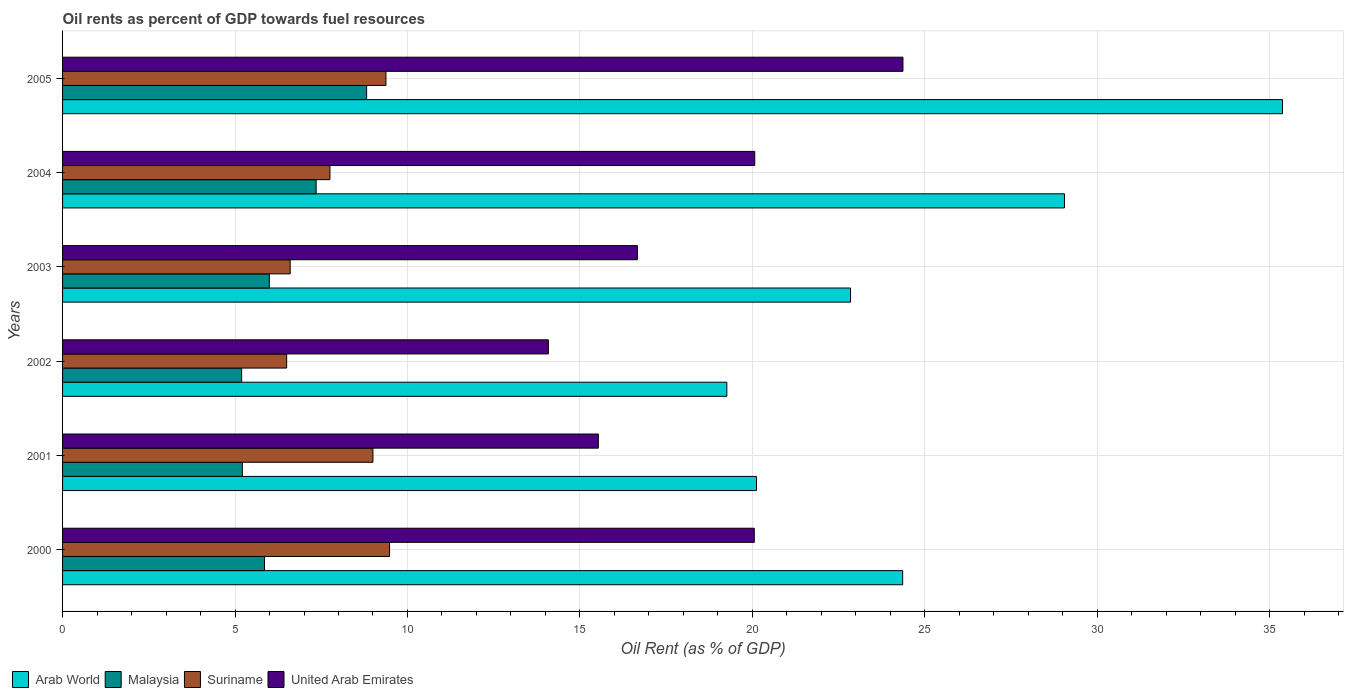How many different coloured bars are there?
Keep it short and to the point. 4. What is the oil rent in Arab World in 2001?
Your response must be concise. 20.12. Across all years, what is the maximum oil rent in Arab World?
Provide a short and direct response. 35.37. Across all years, what is the minimum oil rent in Suriname?
Offer a very short reply. 6.5. In which year was the oil rent in Arab World minimum?
Give a very brief answer. 2002. What is the total oil rent in Malaysia in the graph?
Make the answer very short. 38.42. What is the difference between the oil rent in Arab World in 2000 and that in 2003?
Keep it short and to the point. 1.51. What is the difference between the oil rent in United Arab Emirates in 2004 and the oil rent in Malaysia in 2002?
Keep it short and to the point. 14.88. What is the average oil rent in Arab World per year?
Your response must be concise. 25.17. In the year 2005, what is the difference between the oil rent in United Arab Emirates and oil rent in Malaysia?
Your response must be concise. 15.55. What is the ratio of the oil rent in Suriname in 2000 to that in 2001?
Keep it short and to the point. 1.05. Is the oil rent in Arab World in 2002 less than that in 2004?
Keep it short and to the point. Yes. What is the difference between the highest and the second highest oil rent in Suriname?
Your answer should be compact. 0.11. What is the difference between the highest and the lowest oil rent in Arab World?
Provide a short and direct response. 16.11. In how many years, is the oil rent in Arab World greater than the average oil rent in Arab World taken over all years?
Provide a succinct answer. 2. Is the sum of the oil rent in Malaysia in 2001 and 2005 greater than the maximum oil rent in Arab World across all years?
Keep it short and to the point. No. What does the 1st bar from the top in 2003 represents?
Your answer should be very brief. United Arab Emirates. What does the 4th bar from the bottom in 2004 represents?
Your answer should be compact. United Arab Emirates. How many bars are there?
Your answer should be very brief. 24. Are all the bars in the graph horizontal?
Make the answer very short. Yes. What is the difference between two consecutive major ticks on the X-axis?
Ensure brevity in your answer.  5. Are the values on the major ticks of X-axis written in scientific E-notation?
Your answer should be very brief. No. Does the graph contain any zero values?
Your response must be concise. No. Does the graph contain grids?
Your answer should be very brief. Yes. How many legend labels are there?
Your answer should be compact. 4. What is the title of the graph?
Offer a terse response. Oil rents as percent of GDP towards fuel resources. Does "French Polynesia" appear as one of the legend labels in the graph?
Offer a very short reply. No. What is the label or title of the X-axis?
Ensure brevity in your answer.  Oil Rent (as % of GDP). What is the label or title of the Y-axis?
Provide a succinct answer. Years. What is the Oil Rent (as % of GDP) in Arab World in 2000?
Ensure brevity in your answer.  24.36. What is the Oil Rent (as % of GDP) of Malaysia in 2000?
Ensure brevity in your answer.  5.85. What is the Oil Rent (as % of GDP) in Suriname in 2000?
Your answer should be compact. 9.48. What is the Oil Rent (as % of GDP) in United Arab Emirates in 2000?
Offer a terse response. 20.06. What is the Oil Rent (as % of GDP) in Arab World in 2001?
Give a very brief answer. 20.12. What is the Oil Rent (as % of GDP) in Malaysia in 2001?
Your answer should be very brief. 5.21. What is the Oil Rent (as % of GDP) of Suriname in 2001?
Keep it short and to the point. 9. What is the Oil Rent (as % of GDP) of United Arab Emirates in 2001?
Your answer should be compact. 15.53. What is the Oil Rent (as % of GDP) of Arab World in 2002?
Ensure brevity in your answer.  19.26. What is the Oil Rent (as % of GDP) of Malaysia in 2002?
Make the answer very short. 5.19. What is the Oil Rent (as % of GDP) in Suriname in 2002?
Provide a short and direct response. 6.5. What is the Oil Rent (as % of GDP) in United Arab Emirates in 2002?
Make the answer very short. 14.09. What is the Oil Rent (as % of GDP) of Arab World in 2003?
Your answer should be compact. 22.85. What is the Oil Rent (as % of GDP) of Malaysia in 2003?
Ensure brevity in your answer.  5.99. What is the Oil Rent (as % of GDP) in Suriname in 2003?
Provide a short and direct response. 6.6. What is the Oil Rent (as % of GDP) in United Arab Emirates in 2003?
Make the answer very short. 16.67. What is the Oil Rent (as % of GDP) in Arab World in 2004?
Your answer should be very brief. 29.05. What is the Oil Rent (as % of GDP) in Malaysia in 2004?
Your response must be concise. 7.35. What is the Oil Rent (as % of GDP) in Suriname in 2004?
Offer a terse response. 7.75. What is the Oil Rent (as % of GDP) of United Arab Emirates in 2004?
Make the answer very short. 20.07. What is the Oil Rent (as % of GDP) in Arab World in 2005?
Provide a short and direct response. 35.37. What is the Oil Rent (as % of GDP) of Malaysia in 2005?
Your answer should be very brief. 8.82. What is the Oil Rent (as % of GDP) of Suriname in 2005?
Offer a terse response. 9.38. What is the Oil Rent (as % of GDP) of United Arab Emirates in 2005?
Provide a succinct answer. 24.37. Across all years, what is the maximum Oil Rent (as % of GDP) in Arab World?
Offer a terse response. 35.37. Across all years, what is the maximum Oil Rent (as % of GDP) of Malaysia?
Your response must be concise. 8.82. Across all years, what is the maximum Oil Rent (as % of GDP) of Suriname?
Ensure brevity in your answer.  9.48. Across all years, what is the maximum Oil Rent (as % of GDP) in United Arab Emirates?
Make the answer very short. 24.37. Across all years, what is the minimum Oil Rent (as % of GDP) in Arab World?
Give a very brief answer. 19.26. Across all years, what is the minimum Oil Rent (as % of GDP) in Malaysia?
Offer a very short reply. 5.19. Across all years, what is the minimum Oil Rent (as % of GDP) of Suriname?
Your response must be concise. 6.5. Across all years, what is the minimum Oil Rent (as % of GDP) of United Arab Emirates?
Provide a succinct answer. 14.09. What is the total Oil Rent (as % of GDP) of Arab World in the graph?
Ensure brevity in your answer.  151. What is the total Oil Rent (as % of GDP) in Malaysia in the graph?
Your response must be concise. 38.42. What is the total Oil Rent (as % of GDP) in Suriname in the graph?
Offer a terse response. 48.7. What is the total Oil Rent (as % of GDP) of United Arab Emirates in the graph?
Give a very brief answer. 110.78. What is the difference between the Oil Rent (as % of GDP) in Arab World in 2000 and that in 2001?
Your answer should be compact. 4.24. What is the difference between the Oil Rent (as % of GDP) of Malaysia in 2000 and that in 2001?
Offer a very short reply. 0.64. What is the difference between the Oil Rent (as % of GDP) in Suriname in 2000 and that in 2001?
Your answer should be compact. 0.48. What is the difference between the Oil Rent (as % of GDP) in United Arab Emirates in 2000 and that in 2001?
Offer a terse response. 4.52. What is the difference between the Oil Rent (as % of GDP) of Arab World in 2000 and that in 2002?
Your response must be concise. 5.1. What is the difference between the Oil Rent (as % of GDP) in Malaysia in 2000 and that in 2002?
Your answer should be compact. 0.66. What is the difference between the Oil Rent (as % of GDP) in Suriname in 2000 and that in 2002?
Offer a terse response. 2.98. What is the difference between the Oil Rent (as % of GDP) of United Arab Emirates in 2000 and that in 2002?
Offer a terse response. 5.97. What is the difference between the Oil Rent (as % of GDP) in Arab World in 2000 and that in 2003?
Offer a very short reply. 1.51. What is the difference between the Oil Rent (as % of GDP) of Malaysia in 2000 and that in 2003?
Provide a succinct answer. -0.14. What is the difference between the Oil Rent (as % of GDP) in Suriname in 2000 and that in 2003?
Give a very brief answer. 2.88. What is the difference between the Oil Rent (as % of GDP) of United Arab Emirates in 2000 and that in 2003?
Make the answer very short. 3.39. What is the difference between the Oil Rent (as % of GDP) in Arab World in 2000 and that in 2004?
Make the answer very short. -4.69. What is the difference between the Oil Rent (as % of GDP) of Malaysia in 2000 and that in 2004?
Offer a terse response. -1.5. What is the difference between the Oil Rent (as % of GDP) of Suriname in 2000 and that in 2004?
Your answer should be compact. 1.73. What is the difference between the Oil Rent (as % of GDP) in United Arab Emirates in 2000 and that in 2004?
Offer a very short reply. -0.01. What is the difference between the Oil Rent (as % of GDP) in Arab World in 2000 and that in 2005?
Provide a short and direct response. -11.01. What is the difference between the Oil Rent (as % of GDP) in Malaysia in 2000 and that in 2005?
Provide a short and direct response. -2.96. What is the difference between the Oil Rent (as % of GDP) in Suriname in 2000 and that in 2005?
Give a very brief answer. 0.11. What is the difference between the Oil Rent (as % of GDP) in United Arab Emirates in 2000 and that in 2005?
Ensure brevity in your answer.  -4.31. What is the difference between the Oil Rent (as % of GDP) in Arab World in 2001 and that in 2002?
Keep it short and to the point. 0.86. What is the difference between the Oil Rent (as % of GDP) of Malaysia in 2001 and that in 2002?
Give a very brief answer. 0.02. What is the difference between the Oil Rent (as % of GDP) in Suriname in 2001 and that in 2002?
Keep it short and to the point. 2.5. What is the difference between the Oil Rent (as % of GDP) of United Arab Emirates in 2001 and that in 2002?
Your answer should be compact. 1.45. What is the difference between the Oil Rent (as % of GDP) of Arab World in 2001 and that in 2003?
Your answer should be compact. -2.73. What is the difference between the Oil Rent (as % of GDP) in Malaysia in 2001 and that in 2003?
Keep it short and to the point. -0.78. What is the difference between the Oil Rent (as % of GDP) of Suriname in 2001 and that in 2003?
Your answer should be compact. 2.4. What is the difference between the Oil Rent (as % of GDP) of United Arab Emirates in 2001 and that in 2003?
Your answer should be very brief. -1.13. What is the difference between the Oil Rent (as % of GDP) in Arab World in 2001 and that in 2004?
Keep it short and to the point. -8.93. What is the difference between the Oil Rent (as % of GDP) of Malaysia in 2001 and that in 2004?
Provide a succinct answer. -2.14. What is the difference between the Oil Rent (as % of GDP) in Suriname in 2001 and that in 2004?
Your answer should be very brief. 1.25. What is the difference between the Oil Rent (as % of GDP) in United Arab Emirates in 2001 and that in 2004?
Your answer should be compact. -4.53. What is the difference between the Oil Rent (as % of GDP) of Arab World in 2001 and that in 2005?
Your response must be concise. -15.25. What is the difference between the Oil Rent (as % of GDP) in Malaysia in 2001 and that in 2005?
Provide a short and direct response. -3.6. What is the difference between the Oil Rent (as % of GDP) in Suriname in 2001 and that in 2005?
Offer a very short reply. -0.38. What is the difference between the Oil Rent (as % of GDP) in United Arab Emirates in 2001 and that in 2005?
Provide a succinct answer. -8.83. What is the difference between the Oil Rent (as % of GDP) in Arab World in 2002 and that in 2003?
Provide a short and direct response. -3.59. What is the difference between the Oil Rent (as % of GDP) in Malaysia in 2002 and that in 2003?
Give a very brief answer. -0.8. What is the difference between the Oil Rent (as % of GDP) in Suriname in 2002 and that in 2003?
Offer a terse response. -0.1. What is the difference between the Oil Rent (as % of GDP) in United Arab Emirates in 2002 and that in 2003?
Make the answer very short. -2.58. What is the difference between the Oil Rent (as % of GDP) in Arab World in 2002 and that in 2004?
Keep it short and to the point. -9.79. What is the difference between the Oil Rent (as % of GDP) of Malaysia in 2002 and that in 2004?
Provide a succinct answer. -2.16. What is the difference between the Oil Rent (as % of GDP) in Suriname in 2002 and that in 2004?
Offer a terse response. -1.25. What is the difference between the Oil Rent (as % of GDP) in United Arab Emirates in 2002 and that in 2004?
Your answer should be very brief. -5.98. What is the difference between the Oil Rent (as % of GDP) of Arab World in 2002 and that in 2005?
Your answer should be very brief. -16.11. What is the difference between the Oil Rent (as % of GDP) in Malaysia in 2002 and that in 2005?
Ensure brevity in your answer.  -3.62. What is the difference between the Oil Rent (as % of GDP) of Suriname in 2002 and that in 2005?
Make the answer very short. -2.88. What is the difference between the Oil Rent (as % of GDP) in United Arab Emirates in 2002 and that in 2005?
Give a very brief answer. -10.28. What is the difference between the Oil Rent (as % of GDP) in Arab World in 2003 and that in 2004?
Your answer should be compact. -6.2. What is the difference between the Oil Rent (as % of GDP) in Malaysia in 2003 and that in 2004?
Offer a terse response. -1.36. What is the difference between the Oil Rent (as % of GDP) of Suriname in 2003 and that in 2004?
Provide a short and direct response. -1.15. What is the difference between the Oil Rent (as % of GDP) in United Arab Emirates in 2003 and that in 2004?
Offer a very short reply. -3.4. What is the difference between the Oil Rent (as % of GDP) of Arab World in 2003 and that in 2005?
Provide a short and direct response. -12.52. What is the difference between the Oil Rent (as % of GDP) of Malaysia in 2003 and that in 2005?
Your answer should be compact. -2.82. What is the difference between the Oil Rent (as % of GDP) of Suriname in 2003 and that in 2005?
Your answer should be very brief. -2.78. What is the difference between the Oil Rent (as % of GDP) in United Arab Emirates in 2003 and that in 2005?
Your answer should be compact. -7.7. What is the difference between the Oil Rent (as % of GDP) of Arab World in 2004 and that in 2005?
Your answer should be very brief. -6.32. What is the difference between the Oil Rent (as % of GDP) in Malaysia in 2004 and that in 2005?
Give a very brief answer. -1.46. What is the difference between the Oil Rent (as % of GDP) in Suriname in 2004 and that in 2005?
Ensure brevity in your answer.  -1.62. What is the difference between the Oil Rent (as % of GDP) of United Arab Emirates in 2004 and that in 2005?
Provide a succinct answer. -4.3. What is the difference between the Oil Rent (as % of GDP) in Arab World in 2000 and the Oil Rent (as % of GDP) in Malaysia in 2001?
Your answer should be compact. 19.14. What is the difference between the Oil Rent (as % of GDP) of Arab World in 2000 and the Oil Rent (as % of GDP) of Suriname in 2001?
Provide a succinct answer. 15.36. What is the difference between the Oil Rent (as % of GDP) of Arab World in 2000 and the Oil Rent (as % of GDP) of United Arab Emirates in 2001?
Offer a terse response. 8.82. What is the difference between the Oil Rent (as % of GDP) of Malaysia in 2000 and the Oil Rent (as % of GDP) of Suriname in 2001?
Offer a terse response. -3.14. What is the difference between the Oil Rent (as % of GDP) of Malaysia in 2000 and the Oil Rent (as % of GDP) of United Arab Emirates in 2001?
Keep it short and to the point. -9.68. What is the difference between the Oil Rent (as % of GDP) in Suriname in 2000 and the Oil Rent (as % of GDP) in United Arab Emirates in 2001?
Offer a terse response. -6.05. What is the difference between the Oil Rent (as % of GDP) in Arab World in 2000 and the Oil Rent (as % of GDP) in Malaysia in 2002?
Ensure brevity in your answer.  19.16. What is the difference between the Oil Rent (as % of GDP) in Arab World in 2000 and the Oil Rent (as % of GDP) in Suriname in 2002?
Your answer should be compact. 17.86. What is the difference between the Oil Rent (as % of GDP) in Arab World in 2000 and the Oil Rent (as % of GDP) in United Arab Emirates in 2002?
Give a very brief answer. 10.27. What is the difference between the Oil Rent (as % of GDP) of Malaysia in 2000 and the Oil Rent (as % of GDP) of Suriname in 2002?
Offer a terse response. -0.64. What is the difference between the Oil Rent (as % of GDP) of Malaysia in 2000 and the Oil Rent (as % of GDP) of United Arab Emirates in 2002?
Your answer should be compact. -8.23. What is the difference between the Oil Rent (as % of GDP) in Suriname in 2000 and the Oil Rent (as % of GDP) in United Arab Emirates in 2002?
Your answer should be very brief. -4.6. What is the difference between the Oil Rent (as % of GDP) in Arab World in 2000 and the Oil Rent (as % of GDP) in Malaysia in 2003?
Provide a short and direct response. 18.36. What is the difference between the Oil Rent (as % of GDP) in Arab World in 2000 and the Oil Rent (as % of GDP) in Suriname in 2003?
Keep it short and to the point. 17.76. What is the difference between the Oil Rent (as % of GDP) in Arab World in 2000 and the Oil Rent (as % of GDP) in United Arab Emirates in 2003?
Provide a short and direct response. 7.69. What is the difference between the Oil Rent (as % of GDP) of Malaysia in 2000 and the Oil Rent (as % of GDP) of Suriname in 2003?
Make the answer very short. -0.74. What is the difference between the Oil Rent (as % of GDP) of Malaysia in 2000 and the Oil Rent (as % of GDP) of United Arab Emirates in 2003?
Ensure brevity in your answer.  -10.81. What is the difference between the Oil Rent (as % of GDP) of Suriname in 2000 and the Oil Rent (as % of GDP) of United Arab Emirates in 2003?
Ensure brevity in your answer.  -7.19. What is the difference between the Oil Rent (as % of GDP) of Arab World in 2000 and the Oil Rent (as % of GDP) of Malaysia in 2004?
Your response must be concise. 17.01. What is the difference between the Oil Rent (as % of GDP) in Arab World in 2000 and the Oil Rent (as % of GDP) in Suriname in 2004?
Keep it short and to the point. 16.61. What is the difference between the Oil Rent (as % of GDP) in Arab World in 2000 and the Oil Rent (as % of GDP) in United Arab Emirates in 2004?
Make the answer very short. 4.29. What is the difference between the Oil Rent (as % of GDP) of Malaysia in 2000 and the Oil Rent (as % of GDP) of Suriname in 2004?
Offer a terse response. -1.9. What is the difference between the Oil Rent (as % of GDP) in Malaysia in 2000 and the Oil Rent (as % of GDP) in United Arab Emirates in 2004?
Your answer should be very brief. -14.21. What is the difference between the Oil Rent (as % of GDP) of Suriname in 2000 and the Oil Rent (as % of GDP) of United Arab Emirates in 2004?
Provide a succinct answer. -10.59. What is the difference between the Oil Rent (as % of GDP) of Arab World in 2000 and the Oil Rent (as % of GDP) of Malaysia in 2005?
Your answer should be very brief. 15.54. What is the difference between the Oil Rent (as % of GDP) of Arab World in 2000 and the Oil Rent (as % of GDP) of Suriname in 2005?
Offer a terse response. 14.98. What is the difference between the Oil Rent (as % of GDP) of Arab World in 2000 and the Oil Rent (as % of GDP) of United Arab Emirates in 2005?
Your response must be concise. -0.01. What is the difference between the Oil Rent (as % of GDP) of Malaysia in 2000 and the Oil Rent (as % of GDP) of Suriname in 2005?
Your response must be concise. -3.52. What is the difference between the Oil Rent (as % of GDP) in Malaysia in 2000 and the Oil Rent (as % of GDP) in United Arab Emirates in 2005?
Make the answer very short. -18.51. What is the difference between the Oil Rent (as % of GDP) of Suriname in 2000 and the Oil Rent (as % of GDP) of United Arab Emirates in 2005?
Keep it short and to the point. -14.88. What is the difference between the Oil Rent (as % of GDP) in Arab World in 2001 and the Oil Rent (as % of GDP) in Malaysia in 2002?
Make the answer very short. 14.93. What is the difference between the Oil Rent (as % of GDP) of Arab World in 2001 and the Oil Rent (as % of GDP) of Suriname in 2002?
Keep it short and to the point. 13.62. What is the difference between the Oil Rent (as % of GDP) of Arab World in 2001 and the Oil Rent (as % of GDP) of United Arab Emirates in 2002?
Ensure brevity in your answer.  6.03. What is the difference between the Oil Rent (as % of GDP) of Malaysia in 2001 and the Oil Rent (as % of GDP) of Suriname in 2002?
Give a very brief answer. -1.28. What is the difference between the Oil Rent (as % of GDP) of Malaysia in 2001 and the Oil Rent (as % of GDP) of United Arab Emirates in 2002?
Give a very brief answer. -8.87. What is the difference between the Oil Rent (as % of GDP) in Suriname in 2001 and the Oil Rent (as % of GDP) in United Arab Emirates in 2002?
Offer a terse response. -5.09. What is the difference between the Oil Rent (as % of GDP) of Arab World in 2001 and the Oil Rent (as % of GDP) of Malaysia in 2003?
Ensure brevity in your answer.  14.12. What is the difference between the Oil Rent (as % of GDP) in Arab World in 2001 and the Oil Rent (as % of GDP) in Suriname in 2003?
Your response must be concise. 13.52. What is the difference between the Oil Rent (as % of GDP) in Arab World in 2001 and the Oil Rent (as % of GDP) in United Arab Emirates in 2003?
Your answer should be very brief. 3.45. What is the difference between the Oil Rent (as % of GDP) in Malaysia in 2001 and the Oil Rent (as % of GDP) in Suriname in 2003?
Offer a terse response. -1.39. What is the difference between the Oil Rent (as % of GDP) of Malaysia in 2001 and the Oil Rent (as % of GDP) of United Arab Emirates in 2003?
Your response must be concise. -11.45. What is the difference between the Oil Rent (as % of GDP) of Suriname in 2001 and the Oil Rent (as % of GDP) of United Arab Emirates in 2003?
Offer a terse response. -7.67. What is the difference between the Oil Rent (as % of GDP) in Arab World in 2001 and the Oil Rent (as % of GDP) in Malaysia in 2004?
Offer a terse response. 12.77. What is the difference between the Oil Rent (as % of GDP) in Arab World in 2001 and the Oil Rent (as % of GDP) in Suriname in 2004?
Ensure brevity in your answer.  12.37. What is the difference between the Oil Rent (as % of GDP) of Arab World in 2001 and the Oil Rent (as % of GDP) of United Arab Emirates in 2004?
Provide a succinct answer. 0.05. What is the difference between the Oil Rent (as % of GDP) of Malaysia in 2001 and the Oil Rent (as % of GDP) of Suriname in 2004?
Your response must be concise. -2.54. What is the difference between the Oil Rent (as % of GDP) in Malaysia in 2001 and the Oil Rent (as % of GDP) in United Arab Emirates in 2004?
Offer a very short reply. -14.86. What is the difference between the Oil Rent (as % of GDP) of Suriname in 2001 and the Oil Rent (as % of GDP) of United Arab Emirates in 2004?
Provide a short and direct response. -11.07. What is the difference between the Oil Rent (as % of GDP) of Arab World in 2001 and the Oil Rent (as % of GDP) of Malaysia in 2005?
Your response must be concise. 11.3. What is the difference between the Oil Rent (as % of GDP) of Arab World in 2001 and the Oil Rent (as % of GDP) of Suriname in 2005?
Offer a terse response. 10.74. What is the difference between the Oil Rent (as % of GDP) in Arab World in 2001 and the Oil Rent (as % of GDP) in United Arab Emirates in 2005?
Give a very brief answer. -4.25. What is the difference between the Oil Rent (as % of GDP) in Malaysia in 2001 and the Oil Rent (as % of GDP) in Suriname in 2005?
Offer a terse response. -4.16. What is the difference between the Oil Rent (as % of GDP) of Malaysia in 2001 and the Oil Rent (as % of GDP) of United Arab Emirates in 2005?
Provide a short and direct response. -19.15. What is the difference between the Oil Rent (as % of GDP) in Suriname in 2001 and the Oil Rent (as % of GDP) in United Arab Emirates in 2005?
Give a very brief answer. -15.37. What is the difference between the Oil Rent (as % of GDP) of Arab World in 2002 and the Oil Rent (as % of GDP) of Malaysia in 2003?
Make the answer very short. 13.26. What is the difference between the Oil Rent (as % of GDP) in Arab World in 2002 and the Oil Rent (as % of GDP) in Suriname in 2003?
Give a very brief answer. 12.66. What is the difference between the Oil Rent (as % of GDP) in Arab World in 2002 and the Oil Rent (as % of GDP) in United Arab Emirates in 2003?
Keep it short and to the point. 2.59. What is the difference between the Oil Rent (as % of GDP) of Malaysia in 2002 and the Oil Rent (as % of GDP) of Suriname in 2003?
Offer a very short reply. -1.41. What is the difference between the Oil Rent (as % of GDP) of Malaysia in 2002 and the Oil Rent (as % of GDP) of United Arab Emirates in 2003?
Make the answer very short. -11.47. What is the difference between the Oil Rent (as % of GDP) of Suriname in 2002 and the Oil Rent (as % of GDP) of United Arab Emirates in 2003?
Ensure brevity in your answer.  -10.17. What is the difference between the Oil Rent (as % of GDP) in Arab World in 2002 and the Oil Rent (as % of GDP) in Malaysia in 2004?
Offer a terse response. 11.91. What is the difference between the Oil Rent (as % of GDP) in Arab World in 2002 and the Oil Rent (as % of GDP) in Suriname in 2004?
Your answer should be very brief. 11.51. What is the difference between the Oil Rent (as % of GDP) in Arab World in 2002 and the Oil Rent (as % of GDP) in United Arab Emirates in 2004?
Make the answer very short. -0.81. What is the difference between the Oil Rent (as % of GDP) of Malaysia in 2002 and the Oil Rent (as % of GDP) of Suriname in 2004?
Offer a terse response. -2.56. What is the difference between the Oil Rent (as % of GDP) in Malaysia in 2002 and the Oil Rent (as % of GDP) in United Arab Emirates in 2004?
Keep it short and to the point. -14.88. What is the difference between the Oil Rent (as % of GDP) of Suriname in 2002 and the Oil Rent (as % of GDP) of United Arab Emirates in 2004?
Make the answer very short. -13.57. What is the difference between the Oil Rent (as % of GDP) of Arab World in 2002 and the Oil Rent (as % of GDP) of Malaysia in 2005?
Your answer should be compact. 10.44. What is the difference between the Oil Rent (as % of GDP) of Arab World in 2002 and the Oil Rent (as % of GDP) of Suriname in 2005?
Provide a short and direct response. 9.88. What is the difference between the Oil Rent (as % of GDP) in Arab World in 2002 and the Oil Rent (as % of GDP) in United Arab Emirates in 2005?
Provide a succinct answer. -5.11. What is the difference between the Oil Rent (as % of GDP) of Malaysia in 2002 and the Oil Rent (as % of GDP) of Suriname in 2005?
Ensure brevity in your answer.  -4.18. What is the difference between the Oil Rent (as % of GDP) of Malaysia in 2002 and the Oil Rent (as % of GDP) of United Arab Emirates in 2005?
Provide a short and direct response. -19.17. What is the difference between the Oil Rent (as % of GDP) of Suriname in 2002 and the Oil Rent (as % of GDP) of United Arab Emirates in 2005?
Give a very brief answer. -17.87. What is the difference between the Oil Rent (as % of GDP) of Arab World in 2003 and the Oil Rent (as % of GDP) of Malaysia in 2004?
Ensure brevity in your answer.  15.49. What is the difference between the Oil Rent (as % of GDP) of Arab World in 2003 and the Oil Rent (as % of GDP) of Suriname in 2004?
Provide a short and direct response. 15.09. What is the difference between the Oil Rent (as % of GDP) in Arab World in 2003 and the Oil Rent (as % of GDP) in United Arab Emirates in 2004?
Your answer should be compact. 2.78. What is the difference between the Oil Rent (as % of GDP) of Malaysia in 2003 and the Oil Rent (as % of GDP) of Suriname in 2004?
Offer a very short reply. -1.76. What is the difference between the Oil Rent (as % of GDP) in Malaysia in 2003 and the Oil Rent (as % of GDP) in United Arab Emirates in 2004?
Make the answer very short. -14.07. What is the difference between the Oil Rent (as % of GDP) of Suriname in 2003 and the Oil Rent (as % of GDP) of United Arab Emirates in 2004?
Offer a terse response. -13.47. What is the difference between the Oil Rent (as % of GDP) of Arab World in 2003 and the Oil Rent (as % of GDP) of Malaysia in 2005?
Provide a short and direct response. 14.03. What is the difference between the Oil Rent (as % of GDP) of Arab World in 2003 and the Oil Rent (as % of GDP) of Suriname in 2005?
Make the answer very short. 13.47. What is the difference between the Oil Rent (as % of GDP) of Arab World in 2003 and the Oil Rent (as % of GDP) of United Arab Emirates in 2005?
Ensure brevity in your answer.  -1.52. What is the difference between the Oil Rent (as % of GDP) of Malaysia in 2003 and the Oil Rent (as % of GDP) of Suriname in 2005?
Your answer should be very brief. -3.38. What is the difference between the Oil Rent (as % of GDP) of Malaysia in 2003 and the Oil Rent (as % of GDP) of United Arab Emirates in 2005?
Ensure brevity in your answer.  -18.37. What is the difference between the Oil Rent (as % of GDP) in Suriname in 2003 and the Oil Rent (as % of GDP) in United Arab Emirates in 2005?
Make the answer very short. -17.77. What is the difference between the Oil Rent (as % of GDP) of Arab World in 2004 and the Oil Rent (as % of GDP) of Malaysia in 2005?
Your response must be concise. 20.23. What is the difference between the Oil Rent (as % of GDP) of Arab World in 2004 and the Oil Rent (as % of GDP) of Suriname in 2005?
Keep it short and to the point. 19.67. What is the difference between the Oil Rent (as % of GDP) of Arab World in 2004 and the Oil Rent (as % of GDP) of United Arab Emirates in 2005?
Your answer should be compact. 4.68. What is the difference between the Oil Rent (as % of GDP) of Malaysia in 2004 and the Oil Rent (as % of GDP) of Suriname in 2005?
Your response must be concise. -2.02. What is the difference between the Oil Rent (as % of GDP) in Malaysia in 2004 and the Oil Rent (as % of GDP) in United Arab Emirates in 2005?
Provide a short and direct response. -17.01. What is the difference between the Oil Rent (as % of GDP) of Suriname in 2004 and the Oil Rent (as % of GDP) of United Arab Emirates in 2005?
Ensure brevity in your answer.  -16.61. What is the average Oil Rent (as % of GDP) in Arab World per year?
Keep it short and to the point. 25.17. What is the average Oil Rent (as % of GDP) in Malaysia per year?
Provide a short and direct response. 6.4. What is the average Oil Rent (as % of GDP) of Suriname per year?
Provide a short and direct response. 8.12. What is the average Oil Rent (as % of GDP) of United Arab Emirates per year?
Your answer should be compact. 18.46. In the year 2000, what is the difference between the Oil Rent (as % of GDP) in Arab World and Oil Rent (as % of GDP) in Malaysia?
Provide a short and direct response. 18.5. In the year 2000, what is the difference between the Oil Rent (as % of GDP) of Arab World and Oil Rent (as % of GDP) of Suriname?
Your response must be concise. 14.88. In the year 2000, what is the difference between the Oil Rent (as % of GDP) in Arab World and Oil Rent (as % of GDP) in United Arab Emirates?
Give a very brief answer. 4.3. In the year 2000, what is the difference between the Oil Rent (as % of GDP) of Malaysia and Oil Rent (as % of GDP) of Suriname?
Ensure brevity in your answer.  -3.63. In the year 2000, what is the difference between the Oil Rent (as % of GDP) of Malaysia and Oil Rent (as % of GDP) of United Arab Emirates?
Your answer should be compact. -14.2. In the year 2000, what is the difference between the Oil Rent (as % of GDP) of Suriname and Oil Rent (as % of GDP) of United Arab Emirates?
Your answer should be very brief. -10.57. In the year 2001, what is the difference between the Oil Rent (as % of GDP) of Arab World and Oil Rent (as % of GDP) of Malaysia?
Provide a succinct answer. 14.91. In the year 2001, what is the difference between the Oil Rent (as % of GDP) in Arab World and Oil Rent (as % of GDP) in Suriname?
Offer a terse response. 11.12. In the year 2001, what is the difference between the Oil Rent (as % of GDP) of Arab World and Oil Rent (as % of GDP) of United Arab Emirates?
Your response must be concise. 4.59. In the year 2001, what is the difference between the Oil Rent (as % of GDP) in Malaysia and Oil Rent (as % of GDP) in Suriname?
Keep it short and to the point. -3.79. In the year 2001, what is the difference between the Oil Rent (as % of GDP) in Malaysia and Oil Rent (as % of GDP) in United Arab Emirates?
Provide a succinct answer. -10.32. In the year 2001, what is the difference between the Oil Rent (as % of GDP) of Suriname and Oil Rent (as % of GDP) of United Arab Emirates?
Offer a terse response. -6.54. In the year 2002, what is the difference between the Oil Rent (as % of GDP) of Arab World and Oil Rent (as % of GDP) of Malaysia?
Ensure brevity in your answer.  14.07. In the year 2002, what is the difference between the Oil Rent (as % of GDP) in Arab World and Oil Rent (as % of GDP) in Suriname?
Give a very brief answer. 12.76. In the year 2002, what is the difference between the Oil Rent (as % of GDP) of Arab World and Oil Rent (as % of GDP) of United Arab Emirates?
Ensure brevity in your answer.  5.17. In the year 2002, what is the difference between the Oil Rent (as % of GDP) of Malaysia and Oil Rent (as % of GDP) of Suriname?
Provide a succinct answer. -1.3. In the year 2002, what is the difference between the Oil Rent (as % of GDP) in Malaysia and Oil Rent (as % of GDP) in United Arab Emirates?
Keep it short and to the point. -8.89. In the year 2002, what is the difference between the Oil Rent (as % of GDP) in Suriname and Oil Rent (as % of GDP) in United Arab Emirates?
Offer a very short reply. -7.59. In the year 2003, what is the difference between the Oil Rent (as % of GDP) in Arab World and Oil Rent (as % of GDP) in Malaysia?
Provide a succinct answer. 16.85. In the year 2003, what is the difference between the Oil Rent (as % of GDP) in Arab World and Oil Rent (as % of GDP) in Suriname?
Your answer should be compact. 16.25. In the year 2003, what is the difference between the Oil Rent (as % of GDP) in Arab World and Oil Rent (as % of GDP) in United Arab Emirates?
Provide a succinct answer. 6.18. In the year 2003, what is the difference between the Oil Rent (as % of GDP) in Malaysia and Oil Rent (as % of GDP) in Suriname?
Ensure brevity in your answer.  -0.6. In the year 2003, what is the difference between the Oil Rent (as % of GDP) of Malaysia and Oil Rent (as % of GDP) of United Arab Emirates?
Offer a very short reply. -10.67. In the year 2003, what is the difference between the Oil Rent (as % of GDP) of Suriname and Oil Rent (as % of GDP) of United Arab Emirates?
Your answer should be very brief. -10.07. In the year 2004, what is the difference between the Oil Rent (as % of GDP) of Arab World and Oil Rent (as % of GDP) of Malaysia?
Offer a very short reply. 21.7. In the year 2004, what is the difference between the Oil Rent (as % of GDP) of Arab World and Oil Rent (as % of GDP) of Suriname?
Ensure brevity in your answer.  21.3. In the year 2004, what is the difference between the Oil Rent (as % of GDP) of Arab World and Oil Rent (as % of GDP) of United Arab Emirates?
Your answer should be very brief. 8.98. In the year 2004, what is the difference between the Oil Rent (as % of GDP) of Malaysia and Oil Rent (as % of GDP) of United Arab Emirates?
Give a very brief answer. -12.72. In the year 2004, what is the difference between the Oil Rent (as % of GDP) of Suriname and Oil Rent (as % of GDP) of United Arab Emirates?
Give a very brief answer. -12.32. In the year 2005, what is the difference between the Oil Rent (as % of GDP) in Arab World and Oil Rent (as % of GDP) in Malaysia?
Offer a very short reply. 26.55. In the year 2005, what is the difference between the Oil Rent (as % of GDP) in Arab World and Oil Rent (as % of GDP) in Suriname?
Provide a succinct answer. 25.99. In the year 2005, what is the difference between the Oil Rent (as % of GDP) of Arab World and Oil Rent (as % of GDP) of United Arab Emirates?
Offer a terse response. 11. In the year 2005, what is the difference between the Oil Rent (as % of GDP) in Malaysia and Oil Rent (as % of GDP) in Suriname?
Your response must be concise. -0.56. In the year 2005, what is the difference between the Oil Rent (as % of GDP) of Malaysia and Oil Rent (as % of GDP) of United Arab Emirates?
Offer a terse response. -15.55. In the year 2005, what is the difference between the Oil Rent (as % of GDP) in Suriname and Oil Rent (as % of GDP) in United Arab Emirates?
Offer a very short reply. -14.99. What is the ratio of the Oil Rent (as % of GDP) of Arab World in 2000 to that in 2001?
Ensure brevity in your answer.  1.21. What is the ratio of the Oil Rent (as % of GDP) of Malaysia in 2000 to that in 2001?
Your answer should be compact. 1.12. What is the ratio of the Oil Rent (as % of GDP) of Suriname in 2000 to that in 2001?
Keep it short and to the point. 1.05. What is the ratio of the Oil Rent (as % of GDP) of United Arab Emirates in 2000 to that in 2001?
Keep it short and to the point. 1.29. What is the ratio of the Oil Rent (as % of GDP) in Arab World in 2000 to that in 2002?
Offer a terse response. 1.26. What is the ratio of the Oil Rent (as % of GDP) of Malaysia in 2000 to that in 2002?
Ensure brevity in your answer.  1.13. What is the ratio of the Oil Rent (as % of GDP) of Suriname in 2000 to that in 2002?
Provide a short and direct response. 1.46. What is the ratio of the Oil Rent (as % of GDP) in United Arab Emirates in 2000 to that in 2002?
Your answer should be compact. 1.42. What is the ratio of the Oil Rent (as % of GDP) of Arab World in 2000 to that in 2003?
Ensure brevity in your answer.  1.07. What is the ratio of the Oil Rent (as % of GDP) in Malaysia in 2000 to that in 2003?
Your answer should be compact. 0.98. What is the ratio of the Oil Rent (as % of GDP) of Suriname in 2000 to that in 2003?
Offer a terse response. 1.44. What is the ratio of the Oil Rent (as % of GDP) of United Arab Emirates in 2000 to that in 2003?
Make the answer very short. 1.2. What is the ratio of the Oil Rent (as % of GDP) of Arab World in 2000 to that in 2004?
Ensure brevity in your answer.  0.84. What is the ratio of the Oil Rent (as % of GDP) of Malaysia in 2000 to that in 2004?
Ensure brevity in your answer.  0.8. What is the ratio of the Oil Rent (as % of GDP) in Suriname in 2000 to that in 2004?
Your answer should be compact. 1.22. What is the ratio of the Oil Rent (as % of GDP) in Arab World in 2000 to that in 2005?
Offer a terse response. 0.69. What is the ratio of the Oil Rent (as % of GDP) of Malaysia in 2000 to that in 2005?
Provide a short and direct response. 0.66. What is the ratio of the Oil Rent (as % of GDP) in Suriname in 2000 to that in 2005?
Offer a very short reply. 1.01. What is the ratio of the Oil Rent (as % of GDP) in United Arab Emirates in 2000 to that in 2005?
Ensure brevity in your answer.  0.82. What is the ratio of the Oil Rent (as % of GDP) in Arab World in 2001 to that in 2002?
Provide a short and direct response. 1.04. What is the ratio of the Oil Rent (as % of GDP) in Malaysia in 2001 to that in 2002?
Your answer should be very brief. 1. What is the ratio of the Oil Rent (as % of GDP) of Suriname in 2001 to that in 2002?
Keep it short and to the point. 1.39. What is the ratio of the Oil Rent (as % of GDP) in United Arab Emirates in 2001 to that in 2002?
Give a very brief answer. 1.1. What is the ratio of the Oil Rent (as % of GDP) of Arab World in 2001 to that in 2003?
Provide a short and direct response. 0.88. What is the ratio of the Oil Rent (as % of GDP) in Malaysia in 2001 to that in 2003?
Make the answer very short. 0.87. What is the ratio of the Oil Rent (as % of GDP) of Suriname in 2001 to that in 2003?
Ensure brevity in your answer.  1.36. What is the ratio of the Oil Rent (as % of GDP) of United Arab Emirates in 2001 to that in 2003?
Offer a terse response. 0.93. What is the ratio of the Oil Rent (as % of GDP) of Arab World in 2001 to that in 2004?
Your answer should be compact. 0.69. What is the ratio of the Oil Rent (as % of GDP) of Malaysia in 2001 to that in 2004?
Offer a terse response. 0.71. What is the ratio of the Oil Rent (as % of GDP) in Suriname in 2001 to that in 2004?
Provide a succinct answer. 1.16. What is the ratio of the Oil Rent (as % of GDP) of United Arab Emirates in 2001 to that in 2004?
Keep it short and to the point. 0.77. What is the ratio of the Oil Rent (as % of GDP) of Arab World in 2001 to that in 2005?
Give a very brief answer. 0.57. What is the ratio of the Oil Rent (as % of GDP) in Malaysia in 2001 to that in 2005?
Offer a very short reply. 0.59. What is the ratio of the Oil Rent (as % of GDP) of Suriname in 2001 to that in 2005?
Give a very brief answer. 0.96. What is the ratio of the Oil Rent (as % of GDP) of United Arab Emirates in 2001 to that in 2005?
Offer a very short reply. 0.64. What is the ratio of the Oil Rent (as % of GDP) of Arab World in 2002 to that in 2003?
Offer a very short reply. 0.84. What is the ratio of the Oil Rent (as % of GDP) in Malaysia in 2002 to that in 2003?
Offer a very short reply. 0.87. What is the ratio of the Oil Rent (as % of GDP) in Suriname in 2002 to that in 2003?
Your answer should be very brief. 0.98. What is the ratio of the Oil Rent (as % of GDP) of United Arab Emirates in 2002 to that in 2003?
Ensure brevity in your answer.  0.85. What is the ratio of the Oil Rent (as % of GDP) of Arab World in 2002 to that in 2004?
Your response must be concise. 0.66. What is the ratio of the Oil Rent (as % of GDP) in Malaysia in 2002 to that in 2004?
Make the answer very short. 0.71. What is the ratio of the Oil Rent (as % of GDP) in Suriname in 2002 to that in 2004?
Your answer should be compact. 0.84. What is the ratio of the Oil Rent (as % of GDP) of United Arab Emirates in 2002 to that in 2004?
Ensure brevity in your answer.  0.7. What is the ratio of the Oil Rent (as % of GDP) in Arab World in 2002 to that in 2005?
Your answer should be compact. 0.54. What is the ratio of the Oil Rent (as % of GDP) in Malaysia in 2002 to that in 2005?
Offer a very short reply. 0.59. What is the ratio of the Oil Rent (as % of GDP) of Suriname in 2002 to that in 2005?
Your response must be concise. 0.69. What is the ratio of the Oil Rent (as % of GDP) of United Arab Emirates in 2002 to that in 2005?
Your answer should be very brief. 0.58. What is the ratio of the Oil Rent (as % of GDP) of Arab World in 2003 to that in 2004?
Your response must be concise. 0.79. What is the ratio of the Oil Rent (as % of GDP) in Malaysia in 2003 to that in 2004?
Ensure brevity in your answer.  0.82. What is the ratio of the Oil Rent (as % of GDP) in Suriname in 2003 to that in 2004?
Your answer should be very brief. 0.85. What is the ratio of the Oil Rent (as % of GDP) in United Arab Emirates in 2003 to that in 2004?
Your response must be concise. 0.83. What is the ratio of the Oil Rent (as % of GDP) in Arab World in 2003 to that in 2005?
Your answer should be very brief. 0.65. What is the ratio of the Oil Rent (as % of GDP) in Malaysia in 2003 to that in 2005?
Provide a succinct answer. 0.68. What is the ratio of the Oil Rent (as % of GDP) in Suriname in 2003 to that in 2005?
Ensure brevity in your answer.  0.7. What is the ratio of the Oil Rent (as % of GDP) of United Arab Emirates in 2003 to that in 2005?
Provide a short and direct response. 0.68. What is the ratio of the Oil Rent (as % of GDP) of Arab World in 2004 to that in 2005?
Provide a short and direct response. 0.82. What is the ratio of the Oil Rent (as % of GDP) in Malaysia in 2004 to that in 2005?
Your answer should be compact. 0.83. What is the ratio of the Oil Rent (as % of GDP) of Suriname in 2004 to that in 2005?
Provide a succinct answer. 0.83. What is the ratio of the Oil Rent (as % of GDP) in United Arab Emirates in 2004 to that in 2005?
Give a very brief answer. 0.82. What is the difference between the highest and the second highest Oil Rent (as % of GDP) of Arab World?
Keep it short and to the point. 6.32. What is the difference between the highest and the second highest Oil Rent (as % of GDP) of Malaysia?
Your answer should be compact. 1.46. What is the difference between the highest and the second highest Oil Rent (as % of GDP) of Suriname?
Provide a succinct answer. 0.11. What is the difference between the highest and the second highest Oil Rent (as % of GDP) of United Arab Emirates?
Your answer should be compact. 4.3. What is the difference between the highest and the lowest Oil Rent (as % of GDP) of Arab World?
Your response must be concise. 16.11. What is the difference between the highest and the lowest Oil Rent (as % of GDP) in Malaysia?
Your response must be concise. 3.62. What is the difference between the highest and the lowest Oil Rent (as % of GDP) in Suriname?
Make the answer very short. 2.98. What is the difference between the highest and the lowest Oil Rent (as % of GDP) in United Arab Emirates?
Make the answer very short. 10.28. 